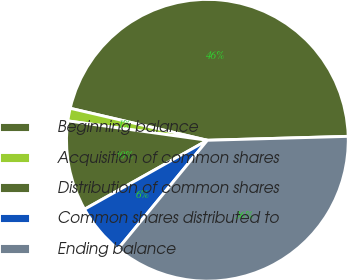<chart> <loc_0><loc_0><loc_500><loc_500><pie_chart><fcel>Beginning balance<fcel>Acquisition of common shares<fcel>Distribution of common shares<fcel>Common shares distributed to<fcel>Ending balance<nl><fcel>45.91%<fcel>1.45%<fcel>10.34%<fcel>5.9%<fcel>36.4%<nl></chart> 